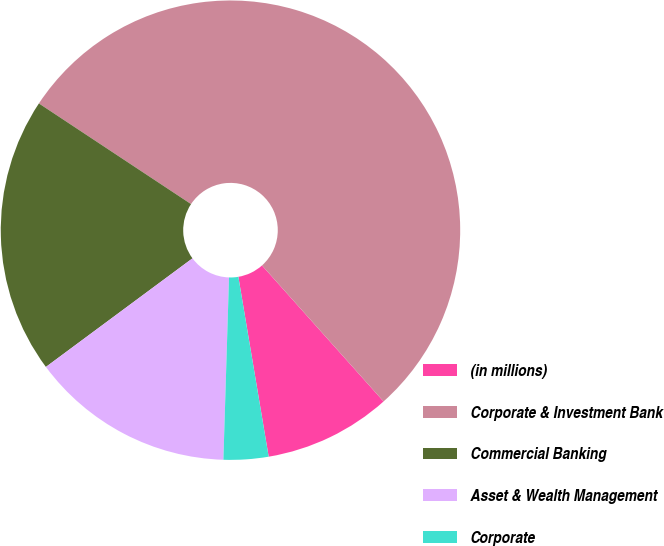<chart> <loc_0><loc_0><loc_500><loc_500><pie_chart><fcel>(in millions)<fcel>Corporate & Investment Bank<fcel>Commercial Banking<fcel>Asset & Wealth Management<fcel>Corporate<nl><fcel>8.95%<fcel>54.09%<fcel>19.45%<fcel>14.36%<fcel>3.15%<nl></chart> 